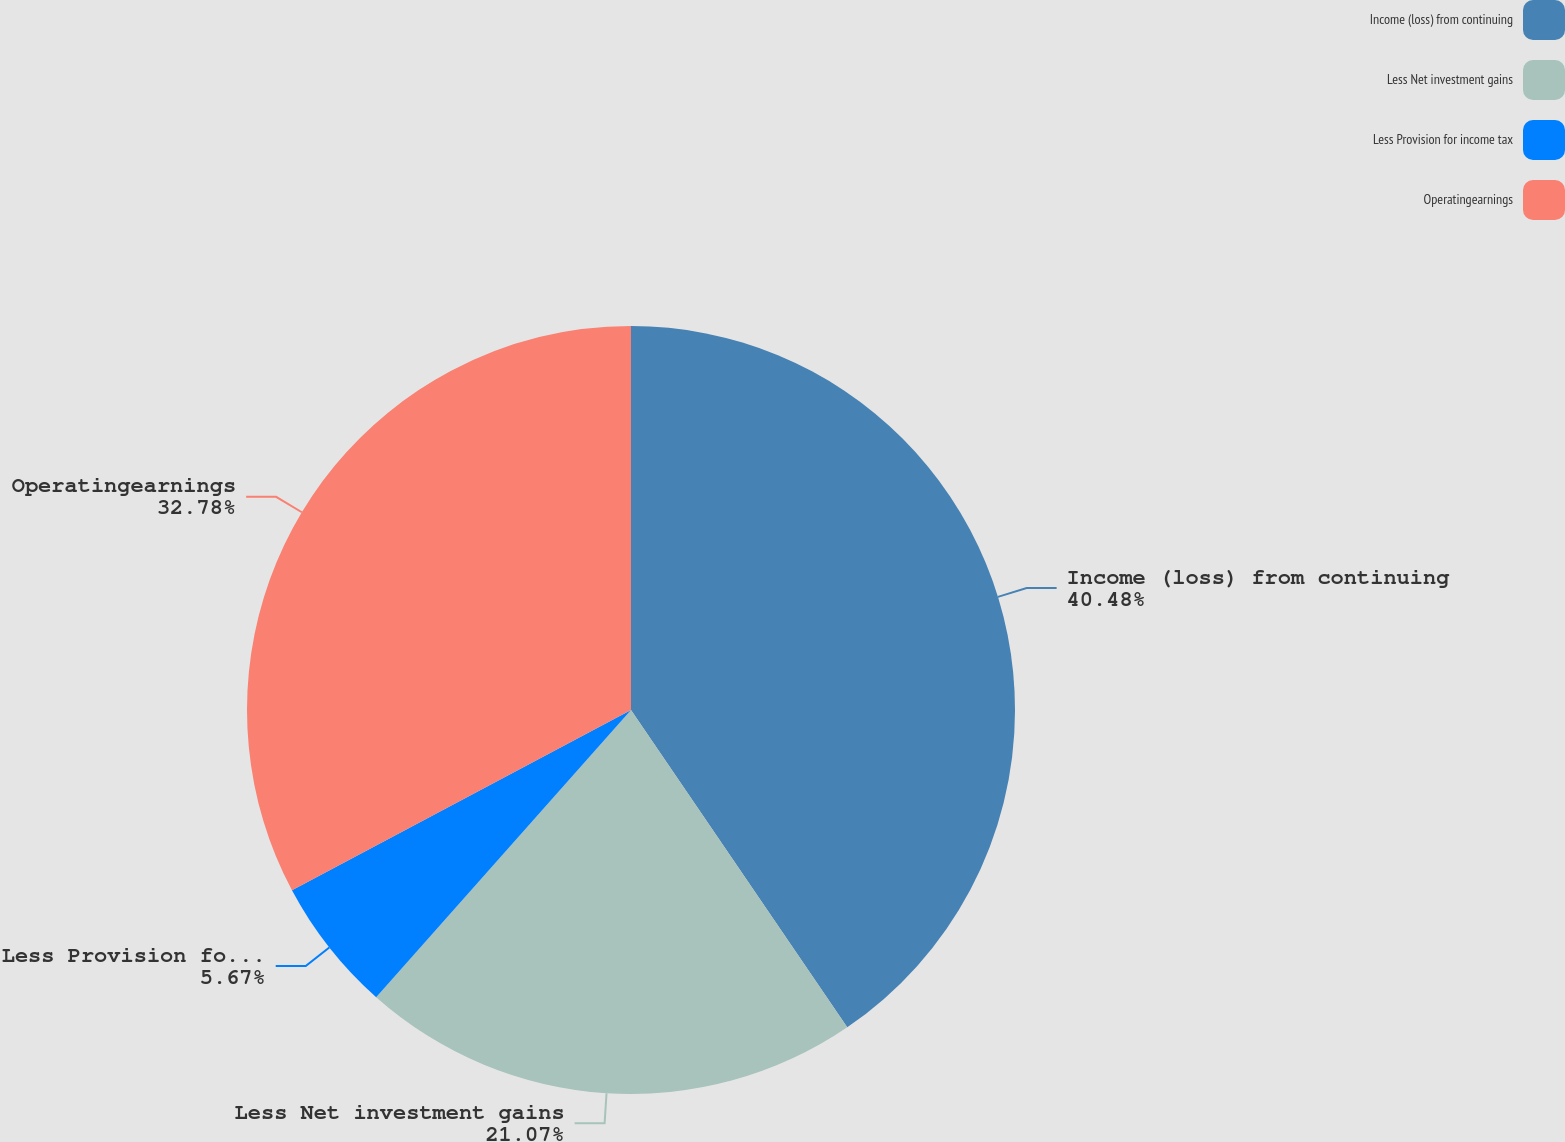Convert chart to OTSL. <chart><loc_0><loc_0><loc_500><loc_500><pie_chart><fcel>Income (loss) from continuing<fcel>Less Net investment gains<fcel>Less Provision for income tax<fcel>Operatingearnings<nl><fcel>40.48%<fcel>21.07%<fcel>5.67%<fcel>32.78%<nl></chart> 